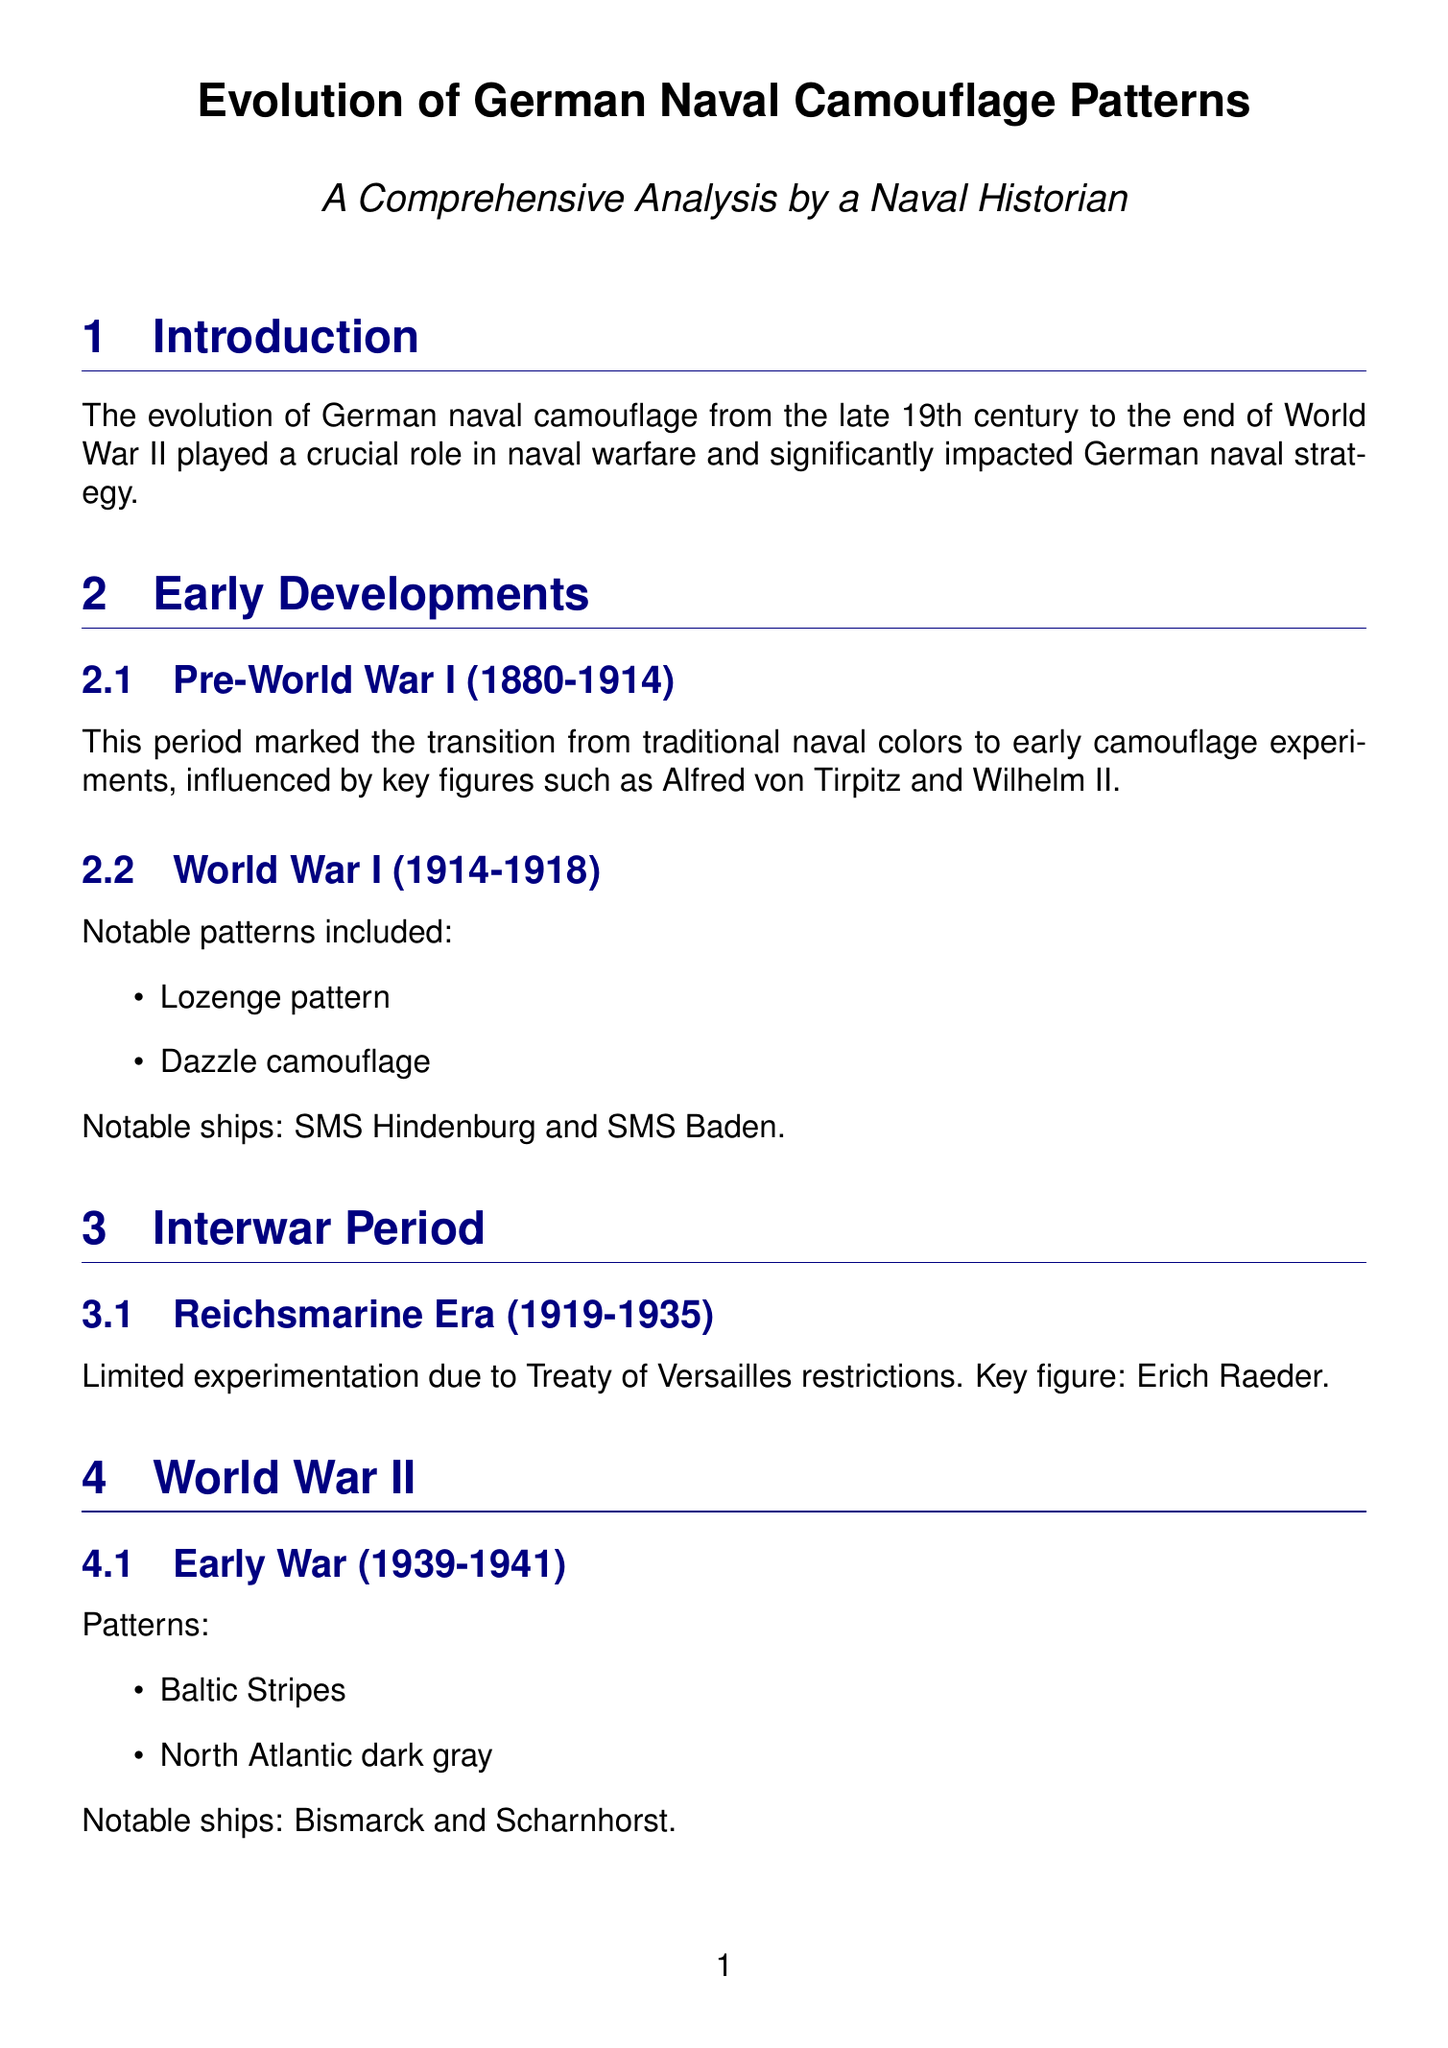What were the notable camouflage patterns used in World War I? The document lists the notable patterns from World War I as: Lozenge pattern and Dazzle camouflage.
Answer: Lozenge pattern, Dazzle camouflage Who was a key figure during the pre-World War I developments? The document states that Alfred von Tirpitz and Wilhelm II were influential during this period.
Answer: Alfred von Tirpitz Which camouflage pattern was associated with the late war period? The document mentions that Splittertarnmuster and Norwegianfjord camouflage were used during the late war.
Answer: Splittertarnmuster, Norwegianfjord camouflage What factors affected the effectiveness of camouflage in surface engagements? The document specifies weather conditions, time of day, and naval radar technology as factors affecting effectiveness.
Answer: Weather conditions, Time of day, Naval radar technology What was the main restriction faced during the Reichsmarine era? The document states that the Treaty of Versailles imposed limitations on experimentation during this period.
Answer: Treaty of Versailles Which ship was notable during the early war period in World War II? The document lists Bismarck and Scharnhorst as notable ships for this period.
Answer: Bismarck What was one of the advancements in camouflage technology mentioned? The document highlights special paints and non-reflective coatings as advancements in camouflage technology.
Answer: Special paints, Non-reflective coatings How did German naval camouflage compare to other navies in terms of strengths? The document claims that German camouflage was noted for its attention to detail and adaptability when compared to other navies.
Answer: Attention to detail, adaptability What type of camouflage was used for submarine warfare? The document states that U-boat camouflage was adapted for effectiveness in different oceanic regions.
Answer: U-boat camouflage 